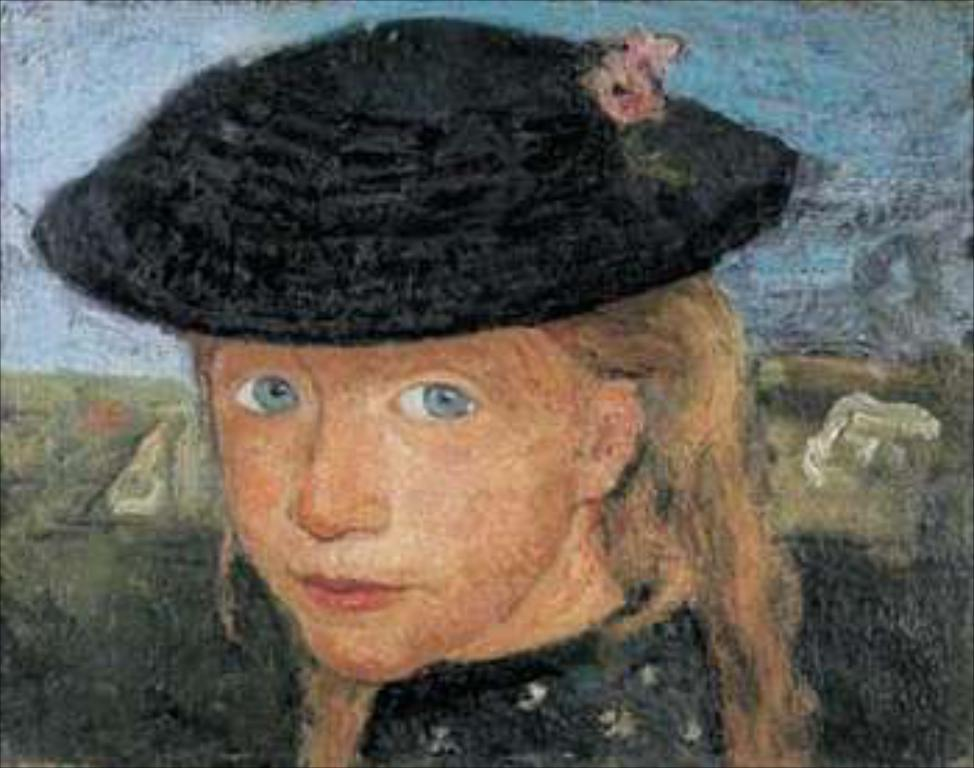What is depicted in the image? There is a painting of a girl in the image. What is the girl wearing in the painting? The girl is wearing a cap in the painting. What can be seen in the background of the painting? The background of the painting includes the sky. What is the texture of the girl's tongue in the painting? There is no mention of the girl's tongue in the provided facts, so we cannot determine its texture from the image. 